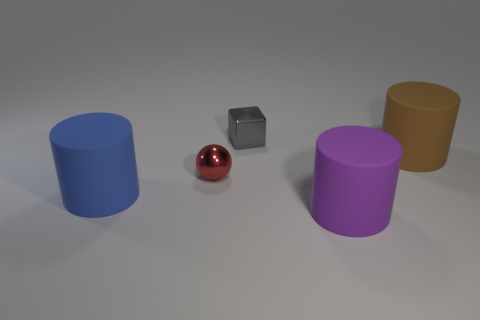Is there another metal thing that has the same size as the gray metal thing?
Offer a terse response. Yes. There is a large rubber object to the left of the gray metal object; what color is it?
Ensure brevity in your answer.  Blue. Are there any gray metallic cubes to the right of the brown matte object that is right of the small gray thing?
Provide a short and direct response. No. What number of other objects are there of the same color as the metallic cube?
Your response must be concise. 0. There is a shiny object in front of the small cube; is its size the same as the matte cylinder that is right of the purple object?
Make the answer very short. No. How big is the cylinder that is behind the big object that is on the left side of the purple matte object?
Offer a very short reply. Large. What is the thing that is in front of the large brown matte cylinder and behind the blue cylinder made of?
Ensure brevity in your answer.  Metal. The small sphere is what color?
Your response must be concise. Red. Is there anything else that has the same material as the brown cylinder?
Make the answer very short. Yes. What shape is the tiny metallic thing in front of the block?
Offer a terse response. Sphere. 